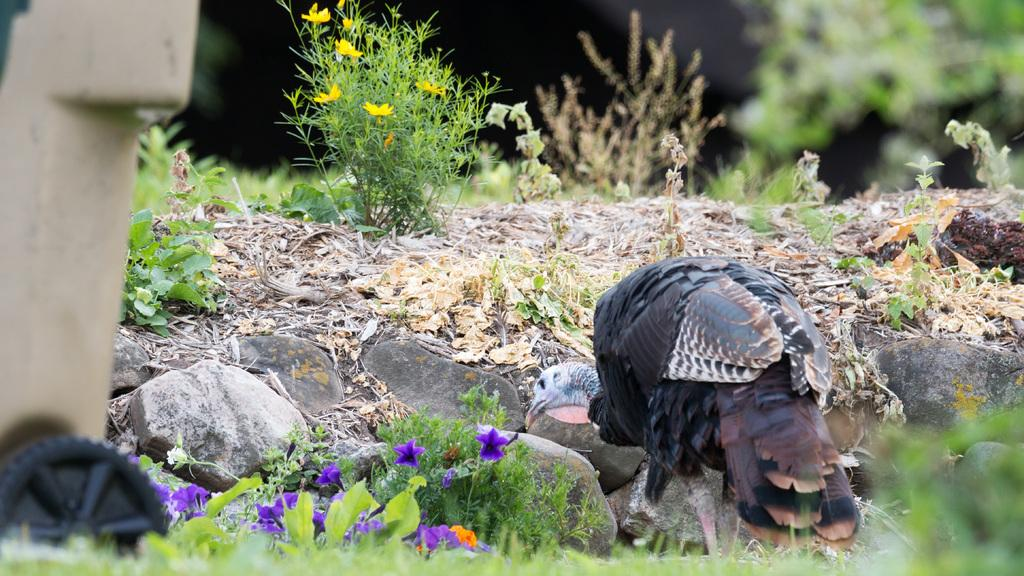What type of animal can be seen in the image? There is a bird in the image. What other elements are present in the image besides the bird? There are plants and rocks on the ground in the image. Where is the dustbin located in the image? The dustbin is on the left side of the image. Can you describe the interaction between the cub and its parent in the image? There is no cub or parent present in the image; it features a bird, plants, rocks, and a dustbin. 